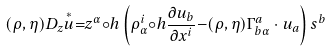Convert formula to latex. <formula><loc_0><loc_0><loc_500><loc_500>( \rho , \eta ) D _ { z } \overset { \ast } { u } { = } z ^ { \alpha } { \circ } h \left ( \rho _ { \alpha } ^ { i } { \circ } h \frac { \partial u _ { b } } { \partial x ^ { i } } { - } ( \rho , \eta ) \Gamma _ { b \alpha } ^ { a } \cdot u _ { a } \right ) s ^ { b }</formula> 